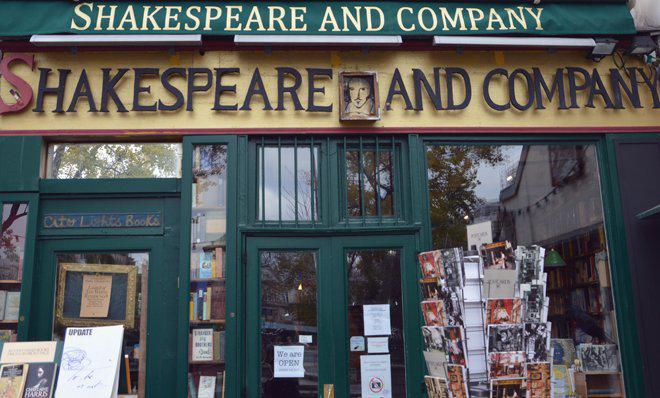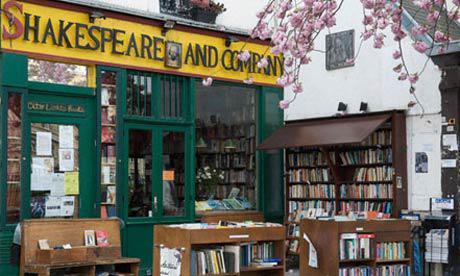The first image is the image on the left, the second image is the image on the right. Analyze the images presented: Is the assertion "There are more than two people at the bookstore in one of the images." valid? Answer yes or no. No. The first image is the image on the left, the second image is the image on the right. Assess this claim about the two images: "Crate-like brown bookshelves stand in front of a green bookstore under its yellow sign.". Correct or not? Answer yes or no. Yes. 